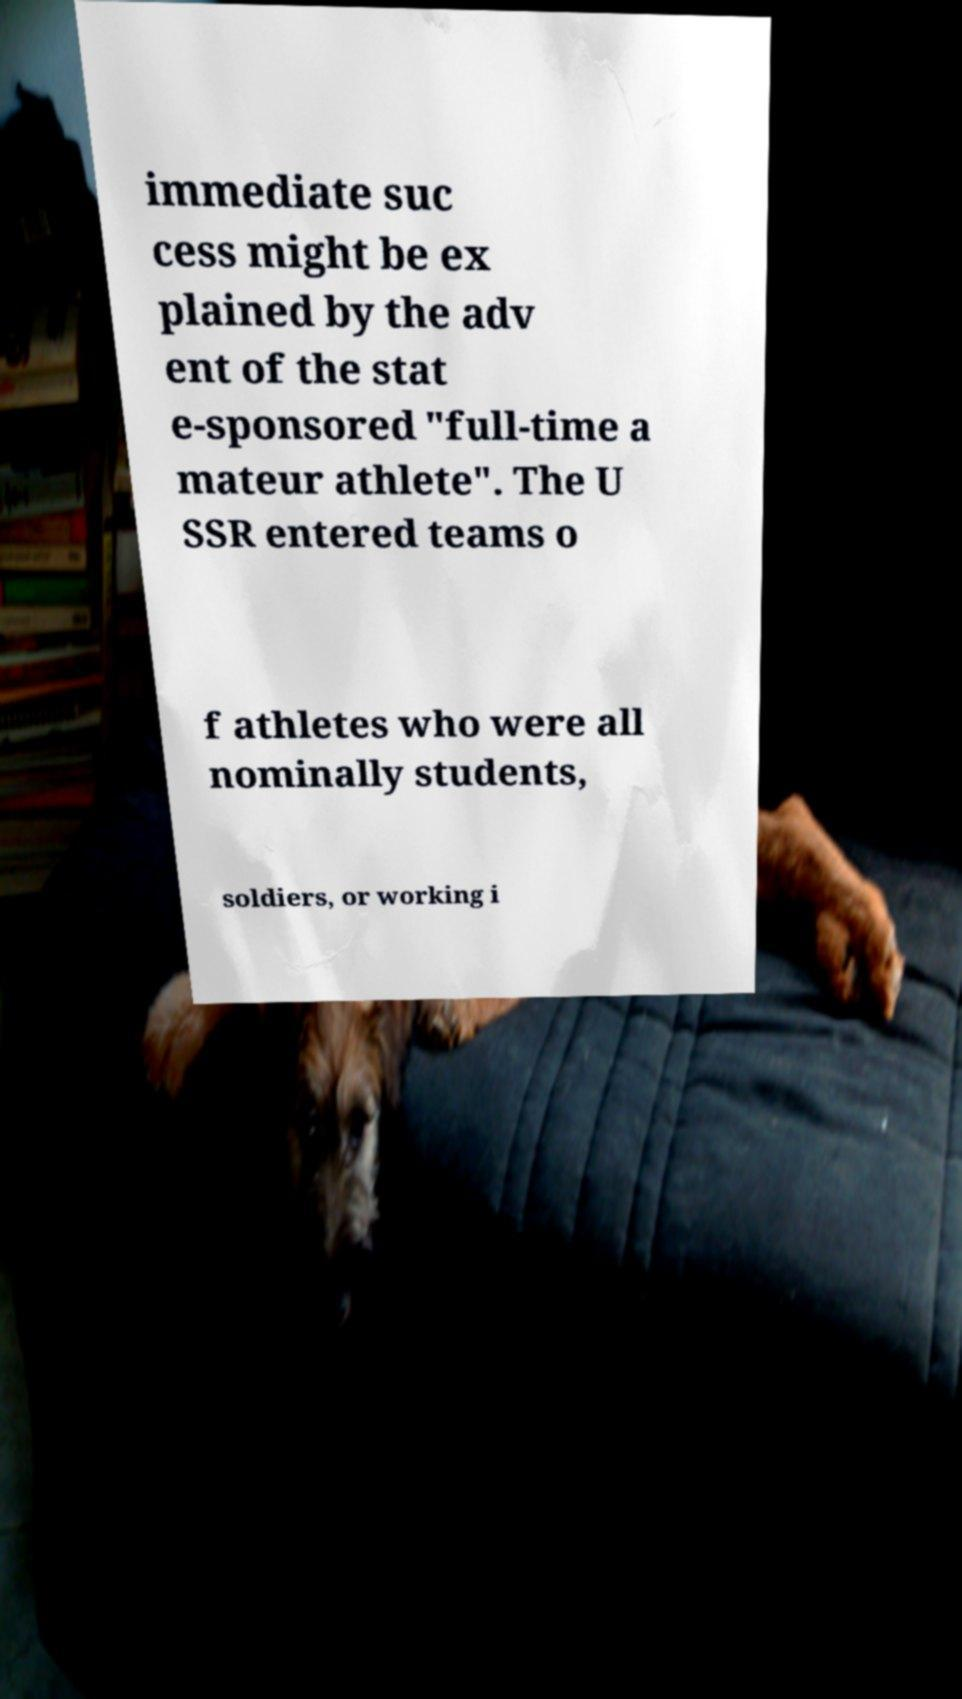Could you assist in decoding the text presented in this image and type it out clearly? immediate suc cess might be ex plained by the adv ent of the stat e-sponsored "full-time a mateur athlete". The U SSR entered teams o f athletes who were all nominally students, soldiers, or working i 